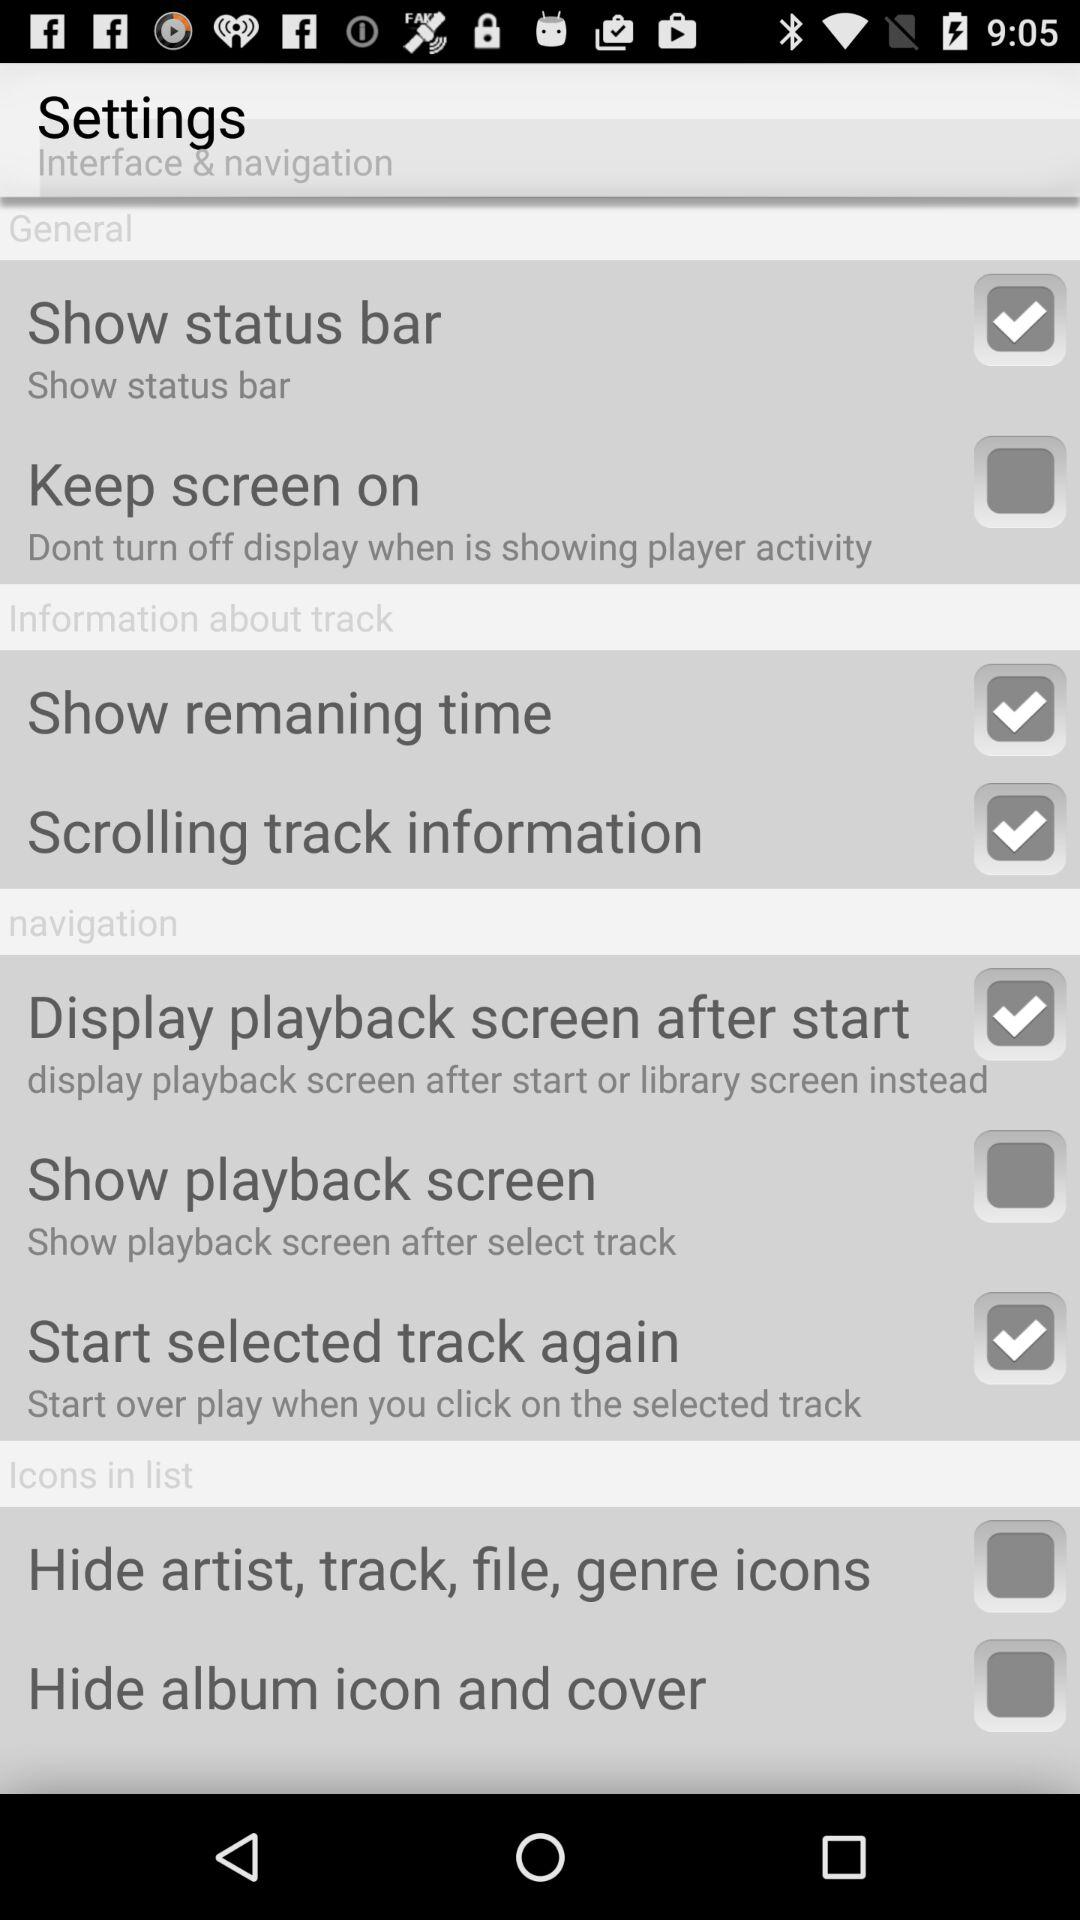What is the status of the "Show status bar"? The status is on. 